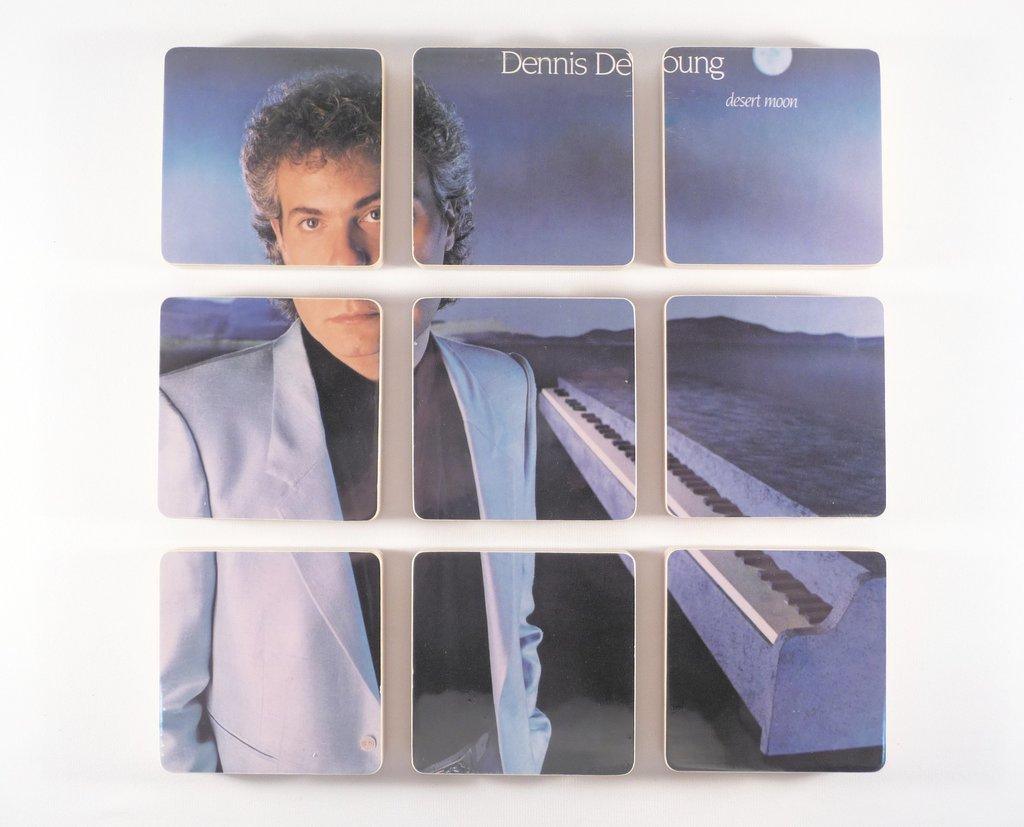What is the main subject of the image? The main subject of the image is a man. What object can be seen in the image besides the man? There is a piano in the image. What celestial body is visible in the sky? There is a moon visible in the sky. What type of fencing is present in the image? There is white fencing in the image. Can you tell me how many kitties are playing with the goose in the image? There are no kitties or geese present in the image. What type of system is being used by the man in the image? There is no system visible in the image; it only features a man, a piano, a moon, and white fencing. 